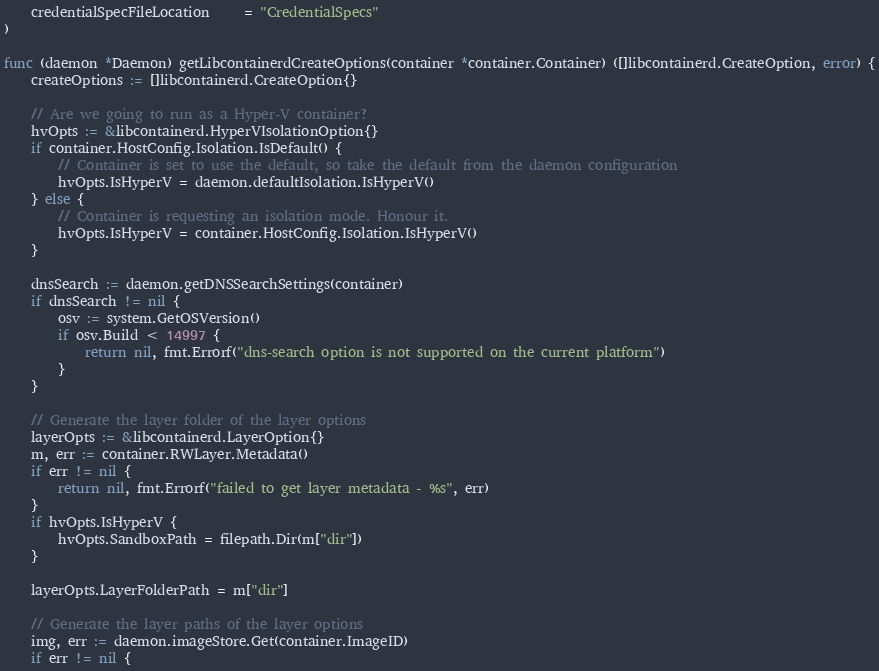Convert code to text. <code><loc_0><loc_0><loc_500><loc_500><_Go_>	credentialSpecFileLocation     = "CredentialSpecs"
)

func (daemon *Daemon) getLibcontainerdCreateOptions(container *container.Container) ([]libcontainerd.CreateOption, error) {
	createOptions := []libcontainerd.CreateOption{}

	// Are we going to run as a Hyper-V container?
	hvOpts := &libcontainerd.HyperVIsolationOption{}
	if container.HostConfig.Isolation.IsDefault() {
		// Container is set to use the default, so take the default from the daemon configuration
		hvOpts.IsHyperV = daemon.defaultIsolation.IsHyperV()
	} else {
		// Container is requesting an isolation mode. Honour it.
		hvOpts.IsHyperV = container.HostConfig.Isolation.IsHyperV()
	}

	dnsSearch := daemon.getDNSSearchSettings(container)
	if dnsSearch != nil {
		osv := system.GetOSVersion()
		if osv.Build < 14997 {
			return nil, fmt.Errorf("dns-search option is not supported on the current platform")
		}
	}

	// Generate the layer folder of the layer options
	layerOpts := &libcontainerd.LayerOption{}
	m, err := container.RWLayer.Metadata()
	if err != nil {
		return nil, fmt.Errorf("failed to get layer metadata - %s", err)
	}
	if hvOpts.IsHyperV {
		hvOpts.SandboxPath = filepath.Dir(m["dir"])
	}

	layerOpts.LayerFolderPath = m["dir"]

	// Generate the layer paths of the layer options
	img, err := daemon.imageStore.Get(container.ImageID)
	if err != nil {</code> 